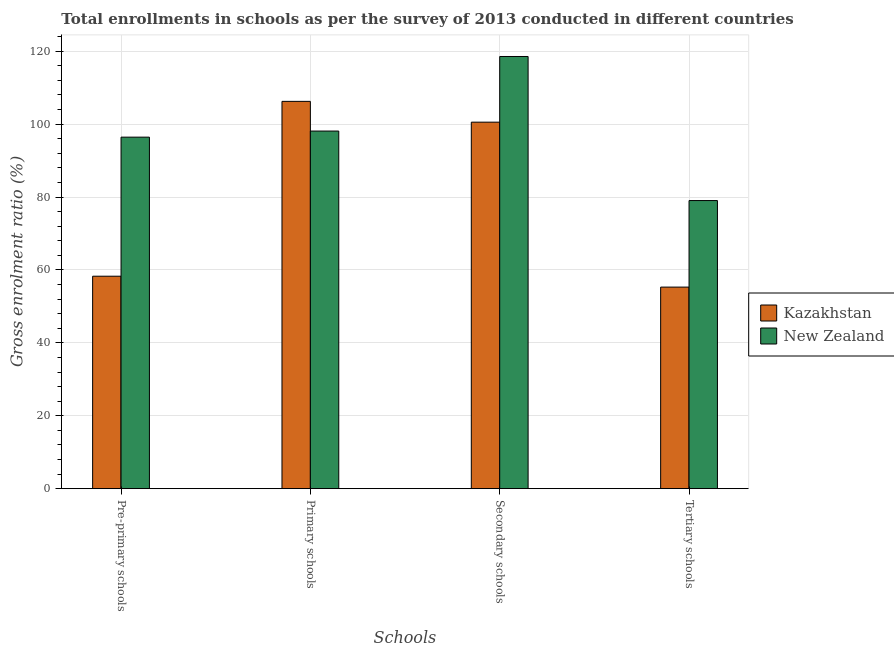How many bars are there on the 3rd tick from the left?
Ensure brevity in your answer.  2. What is the label of the 4th group of bars from the left?
Provide a succinct answer. Tertiary schools. What is the gross enrolment ratio in primary schools in Kazakhstan?
Offer a very short reply. 106.25. Across all countries, what is the maximum gross enrolment ratio in secondary schools?
Provide a succinct answer. 118.56. Across all countries, what is the minimum gross enrolment ratio in secondary schools?
Your answer should be compact. 100.54. In which country was the gross enrolment ratio in pre-primary schools maximum?
Your answer should be very brief. New Zealand. In which country was the gross enrolment ratio in tertiary schools minimum?
Your response must be concise. Kazakhstan. What is the total gross enrolment ratio in primary schools in the graph?
Provide a short and direct response. 204.36. What is the difference between the gross enrolment ratio in tertiary schools in New Zealand and that in Kazakhstan?
Your answer should be very brief. 23.74. What is the difference between the gross enrolment ratio in pre-primary schools in Kazakhstan and the gross enrolment ratio in secondary schools in New Zealand?
Provide a short and direct response. -60.28. What is the average gross enrolment ratio in pre-primary schools per country?
Provide a succinct answer. 77.36. What is the difference between the gross enrolment ratio in secondary schools and gross enrolment ratio in primary schools in Kazakhstan?
Give a very brief answer. -5.71. What is the ratio of the gross enrolment ratio in secondary schools in Kazakhstan to that in New Zealand?
Offer a terse response. 0.85. Is the gross enrolment ratio in tertiary schools in New Zealand less than that in Kazakhstan?
Make the answer very short. No. Is the difference between the gross enrolment ratio in secondary schools in New Zealand and Kazakhstan greater than the difference between the gross enrolment ratio in primary schools in New Zealand and Kazakhstan?
Your answer should be compact. Yes. What is the difference between the highest and the second highest gross enrolment ratio in primary schools?
Your answer should be very brief. 8.14. What is the difference between the highest and the lowest gross enrolment ratio in pre-primary schools?
Offer a terse response. 38.15. In how many countries, is the gross enrolment ratio in tertiary schools greater than the average gross enrolment ratio in tertiary schools taken over all countries?
Provide a succinct answer. 1. Is it the case that in every country, the sum of the gross enrolment ratio in pre-primary schools and gross enrolment ratio in primary schools is greater than the sum of gross enrolment ratio in tertiary schools and gross enrolment ratio in secondary schools?
Keep it short and to the point. No. What does the 1st bar from the left in Primary schools represents?
Offer a very short reply. Kazakhstan. What does the 2nd bar from the right in Secondary schools represents?
Your response must be concise. Kazakhstan. How many bars are there?
Offer a very short reply. 8. Are all the bars in the graph horizontal?
Your response must be concise. No. How many countries are there in the graph?
Offer a very short reply. 2. Does the graph contain any zero values?
Your answer should be compact. No. Does the graph contain grids?
Offer a very short reply. Yes. Where does the legend appear in the graph?
Offer a very short reply. Center right. How are the legend labels stacked?
Your answer should be compact. Vertical. What is the title of the graph?
Your answer should be very brief. Total enrollments in schools as per the survey of 2013 conducted in different countries. What is the label or title of the X-axis?
Provide a short and direct response. Schools. What is the label or title of the Y-axis?
Make the answer very short. Gross enrolment ratio (%). What is the Gross enrolment ratio (%) in Kazakhstan in Pre-primary schools?
Offer a very short reply. 58.29. What is the Gross enrolment ratio (%) of New Zealand in Pre-primary schools?
Keep it short and to the point. 96.43. What is the Gross enrolment ratio (%) in Kazakhstan in Primary schools?
Your answer should be compact. 106.25. What is the Gross enrolment ratio (%) in New Zealand in Primary schools?
Keep it short and to the point. 98.11. What is the Gross enrolment ratio (%) in Kazakhstan in Secondary schools?
Provide a succinct answer. 100.54. What is the Gross enrolment ratio (%) in New Zealand in Secondary schools?
Provide a succinct answer. 118.56. What is the Gross enrolment ratio (%) of Kazakhstan in Tertiary schools?
Make the answer very short. 55.3. What is the Gross enrolment ratio (%) of New Zealand in Tertiary schools?
Your response must be concise. 79.04. Across all Schools, what is the maximum Gross enrolment ratio (%) of Kazakhstan?
Your answer should be compact. 106.25. Across all Schools, what is the maximum Gross enrolment ratio (%) of New Zealand?
Keep it short and to the point. 118.56. Across all Schools, what is the minimum Gross enrolment ratio (%) of Kazakhstan?
Your answer should be very brief. 55.3. Across all Schools, what is the minimum Gross enrolment ratio (%) of New Zealand?
Provide a short and direct response. 79.04. What is the total Gross enrolment ratio (%) of Kazakhstan in the graph?
Offer a very short reply. 320.38. What is the total Gross enrolment ratio (%) in New Zealand in the graph?
Provide a succinct answer. 392.14. What is the difference between the Gross enrolment ratio (%) in Kazakhstan in Pre-primary schools and that in Primary schools?
Your answer should be compact. -47.96. What is the difference between the Gross enrolment ratio (%) in New Zealand in Pre-primary schools and that in Primary schools?
Keep it short and to the point. -1.67. What is the difference between the Gross enrolment ratio (%) in Kazakhstan in Pre-primary schools and that in Secondary schools?
Give a very brief answer. -42.26. What is the difference between the Gross enrolment ratio (%) in New Zealand in Pre-primary schools and that in Secondary schools?
Your answer should be very brief. -22.13. What is the difference between the Gross enrolment ratio (%) of Kazakhstan in Pre-primary schools and that in Tertiary schools?
Ensure brevity in your answer.  2.99. What is the difference between the Gross enrolment ratio (%) of New Zealand in Pre-primary schools and that in Tertiary schools?
Keep it short and to the point. 17.39. What is the difference between the Gross enrolment ratio (%) in Kazakhstan in Primary schools and that in Secondary schools?
Your answer should be compact. 5.71. What is the difference between the Gross enrolment ratio (%) of New Zealand in Primary schools and that in Secondary schools?
Provide a succinct answer. -20.45. What is the difference between the Gross enrolment ratio (%) of Kazakhstan in Primary schools and that in Tertiary schools?
Offer a terse response. 50.95. What is the difference between the Gross enrolment ratio (%) in New Zealand in Primary schools and that in Tertiary schools?
Provide a succinct answer. 19.07. What is the difference between the Gross enrolment ratio (%) in Kazakhstan in Secondary schools and that in Tertiary schools?
Your response must be concise. 45.25. What is the difference between the Gross enrolment ratio (%) in New Zealand in Secondary schools and that in Tertiary schools?
Ensure brevity in your answer.  39.52. What is the difference between the Gross enrolment ratio (%) of Kazakhstan in Pre-primary schools and the Gross enrolment ratio (%) of New Zealand in Primary schools?
Offer a very short reply. -39.82. What is the difference between the Gross enrolment ratio (%) of Kazakhstan in Pre-primary schools and the Gross enrolment ratio (%) of New Zealand in Secondary schools?
Offer a terse response. -60.28. What is the difference between the Gross enrolment ratio (%) in Kazakhstan in Pre-primary schools and the Gross enrolment ratio (%) in New Zealand in Tertiary schools?
Your answer should be compact. -20.75. What is the difference between the Gross enrolment ratio (%) in Kazakhstan in Primary schools and the Gross enrolment ratio (%) in New Zealand in Secondary schools?
Keep it short and to the point. -12.31. What is the difference between the Gross enrolment ratio (%) of Kazakhstan in Primary schools and the Gross enrolment ratio (%) of New Zealand in Tertiary schools?
Make the answer very short. 27.21. What is the difference between the Gross enrolment ratio (%) of Kazakhstan in Secondary schools and the Gross enrolment ratio (%) of New Zealand in Tertiary schools?
Provide a succinct answer. 21.51. What is the average Gross enrolment ratio (%) of Kazakhstan per Schools?
Offer a terse response. 80.09. What is the average Gross enrolment ratio (%) of New Zealand per Schools?
Keep it short and to the point. 98.04. What is the difference between the Gross enrolment ratio (%) in Kazakhstan and Gross enrolment ratio (%) in New Zealand in Pre-primary schools?
Your answer should be compact. -38.15. What is the difference between the Gross enrolment ratio (%) in Kazakhstan and Gross enrolment ratio (%) in New Zealand in Primary schools?
Your answer should be compact. 8.14. What is the difference between the Gross enrolment ratio (%) of Kazakhstan and Gross enrolment ratio (%) of New Zealand in Secondary schools?
Ensure brevity in your answer.  -18.02. What is the difference between the Gross enrolment ratio (%) in Kazakhstan and Gross enrolment ratio (%) in New Zealand in Tertiary schools?
Offer a very short reply. -23.74. What is the ratio of the Gross enrolment ratio (%) in Kazakhstan in Pre-primary schools to that in Primary schools?
Make the answer very short. 0.55. What is the ratio of the Gross enrolment ratio (%) in New Zealand in Pre-primary schools to that in Primary schools?
Give a very brief answer. 0.98. What is the ratio of the Gross enrolment ratio (%) in Kazakhstan in Pre-primary schools to that in Secondary schools?
Your response must be concise. 0.58. What is the ratio of the Gross enrolment ratio (%) of New Zealand in Pre-primary schools to that in Secondary schools?
Your response must be concise. 0.81. What is the ratio of the Gross enrolment ratio (%) in Kazakhstan in Pre-primary schools to that in Tertiary schools?
Keep it short and to the point. 1.05. What is the ratio of the Gross enrolment ratio (%) in New Zealand in Pre-primary schools to that in Tertiary schools?
Provide a short and direct response. 1.22. What is the ratio of the Gross enrolment ratio (%) in Kazakhstan in Primary schools to that in Secondary schools?
Your response must be concise. 1.06. What is the ratio of the Gross enrolment ratio (%) in New Zealand in Primary schools to that in Secondary schools?
Provide a short and direct response. 0.83. What is the ratio of the Gross enrolment ratio (%) of Kazakhstan in Primary schools to that in Tertiary schools?
Keep it short and to the point. 1.92. What is the ratio of the Gross enrolment ratio (%) of New Zealand in Primary schools to that in Tertiary schools?
Give a very brief answer. 1.24. What is the ratio of the Gross enrolment ratio (%) of Kazakhstan in Secondary schools to that in Tertiary schools?
Offer a very short reply. 1.82. What is the ratio of the Gross enrolment ratio (%) of New Zealand in Secondary schools to that in Tertiary schools?
Offer a very short reply. 1.5. What is the difference between the highest and the second highest Gross enrolment ratio (%) in Kazakhstan?
Make the answer very short. 5.71. What is the difference between the highest and the second highest Gross enrolment ratio (%) in New Zealand?
Provide a short and direct response. 20.45. What is the difference between the highest and the lowest Gross enrolment ratio (%) in Kazakhstan?
Provide a succinct answer. 50.95. What is the difference between the highest and the lowest Gross enrolment ratio (%) in New Zealand?
Your response must be concise. 39.52. 